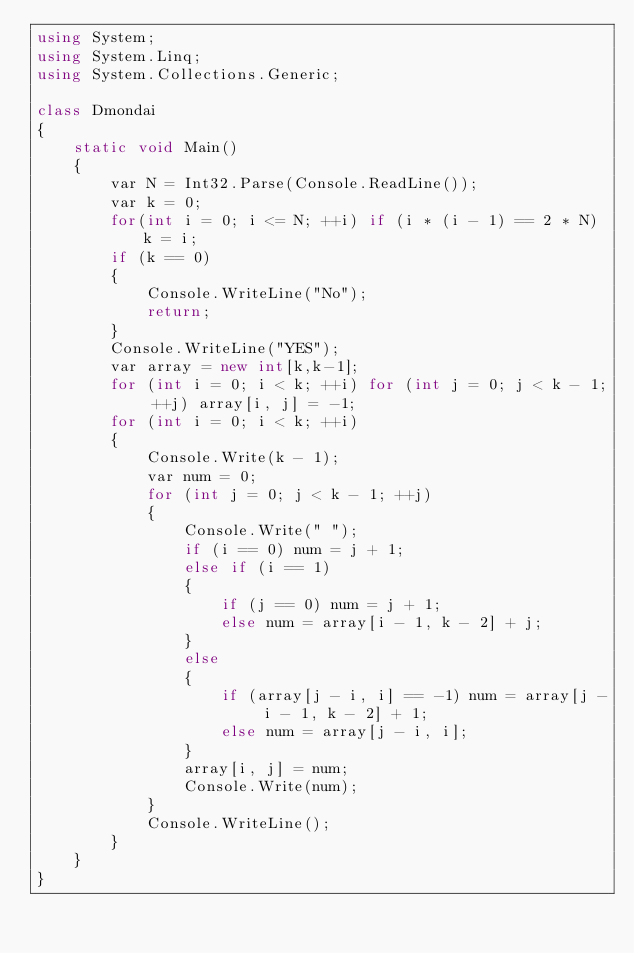Convert code to text. <code><loc_0><loc_0><loc_500><loc_500><_C#_>using System;
using System.Linq;
using System.Collections.Generic;

class Dmondai
{
    static void Main()
    {
        var N = Int32.Parse(Console.ReadLine());
        var k = 0;
        for(int i = 0; i <= N; ++i) if (i * (i - 1) == 2 * N) k = i;
        if (k == 0)
        {
            Console.WriteLine("No");
            return;
        }
        Console.WriteLine("YES");
        var array = new int[k,k-1];
        for (int i = 0; i < k; ++i) for (int j = 0; j < k - 1; ++j) array[i, j] = -1;
        for (int i = 0; i < k; ++i)
        {
            Console.Write(k - 1);
            var num = 0;
            for (int j = 0; j < k - 1; ++j)
            {
                Console.Write(" ");
                if (i == 0) num = j + 1;
                else if (i == 1)
                {
                    if (j == 0) num = j + 1;
                    else num = array[i - 1, k - 2] + j;
                }
                else
                {
                    if (array[j - i, i] == -1) num = array[j - i - 1, k - 2] + 1;
                    else num = array[j - i, i];
                }
                array[i, j] = num;
                Console.Write(num);
            }
            Console.WriteLine();
        }
    }
}</code> 